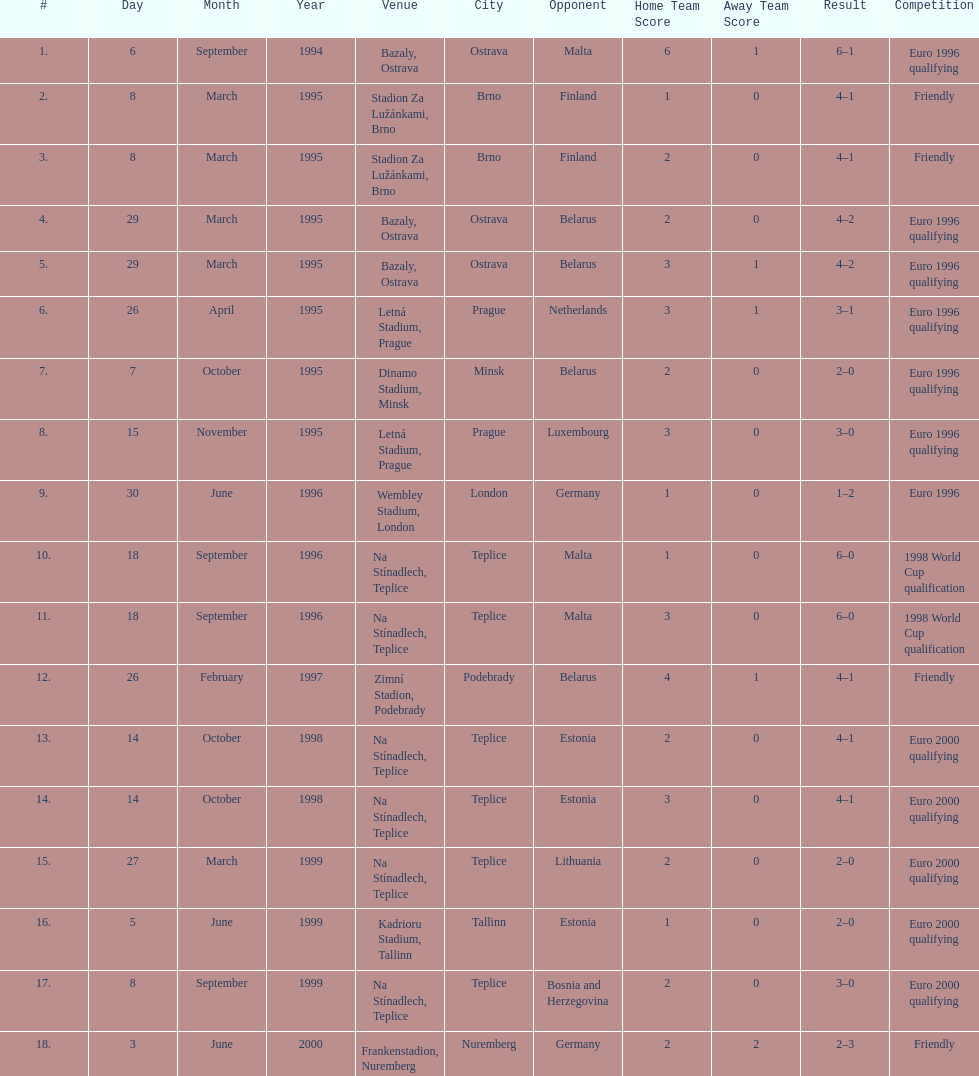List the opponents which are under the friendly competition. Finland, Belarus, Germany. 